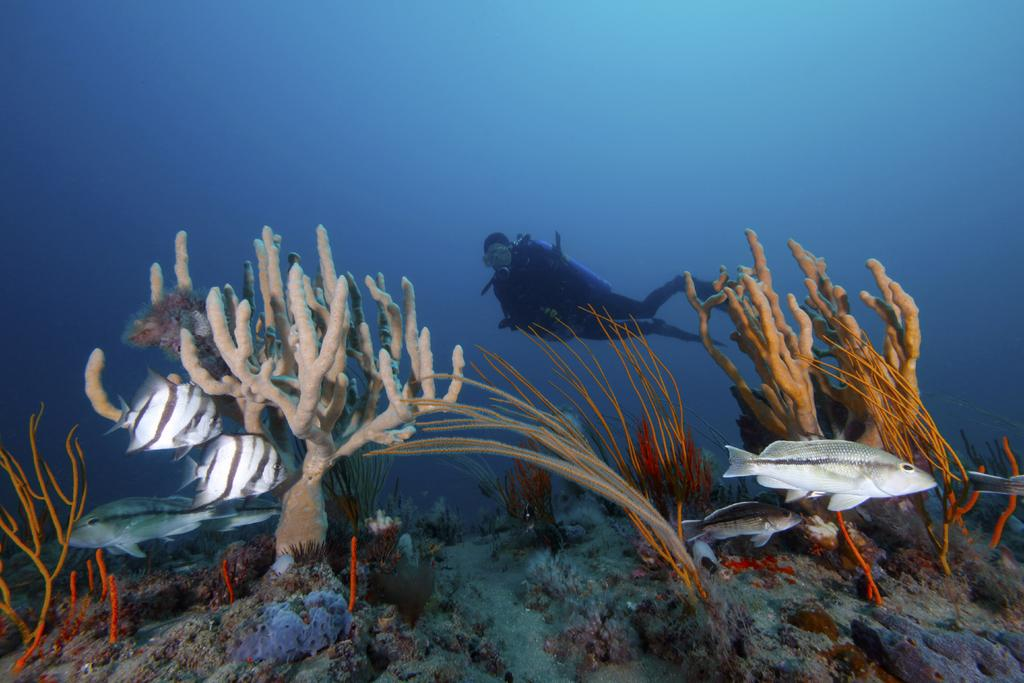What is the person in the image doing? The person is diving into water in the image. What can be seen in the water besides the person? There are water plants and fishes visible in the image. What type of jewel can be seen on the person's head while diving? There is no jewel visible on the person's head while diving in the image. 